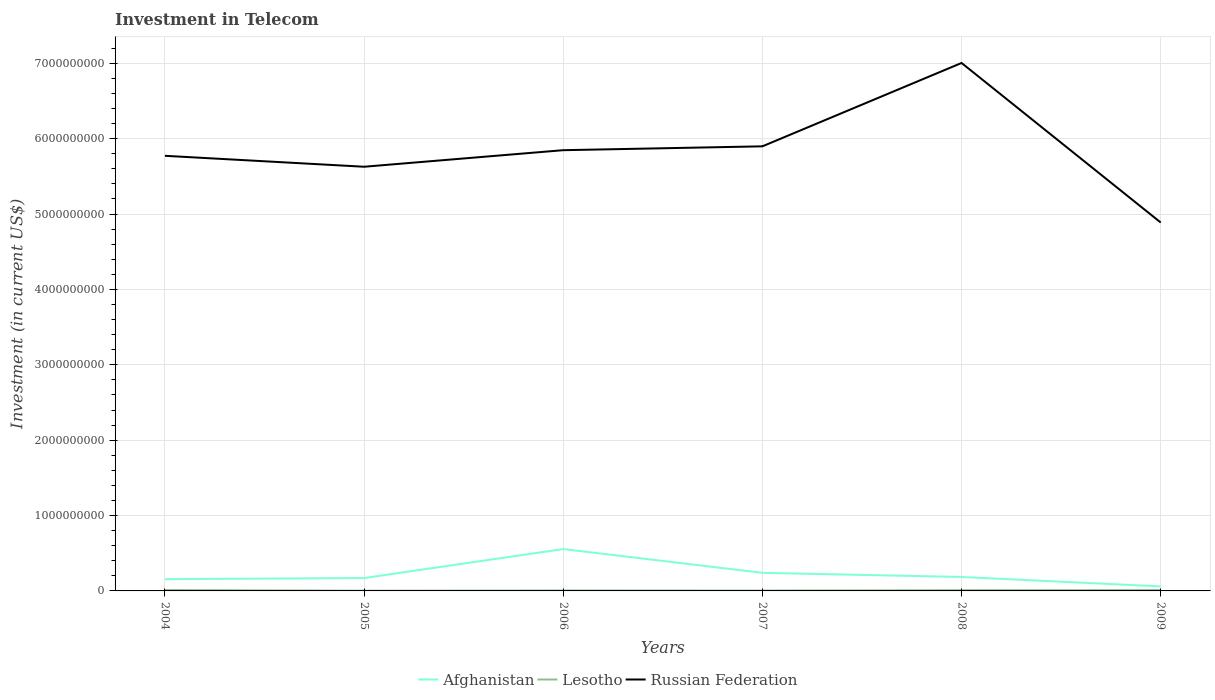How many different coloured lines are there?
Your response must be concise. 3. Is the number of lines equal to the number of legend labels?
Make the answer very short. Yes. Across all years, what is the maximum amount invested in telecom in Russian Federation?
Ensure brevity in your answer.  4.89e+09. In which year was the amount invested in telecom in Russian Federation maximum?
Offer a very short reply. 2009. What is the total amount invested in telecom in Afghanistan in the graph?
Provide a short and direct response. 4.95e+08. What is the difference between the highest and the second highest amount invested in telecom in Afghanistan?
Make the answer very short. 4.95e+08. Is the amount invested in telecom in Lesotho strictly greater than the amount invested in telecom in Russian Federation over the years?
Ensure brevity in your answer.  Yes. How many lines are there?
Provide a succinct answer. 3. How many years are there in the graph?
Offer a terse response. 6. What is the difference between two consecutive major ticks on the Y-axis?
Provide a short and direct response. 1.00e+09. Are the values on the major ticks of Y-axis written in scientific E-notation?
Your answer should be compact. No. Does the graph contain any zero values?
Provide a succinct answer. No. Does the graph contain grids?
Give a very brief answer. Yes. Where does the legend appear in the graph?
Provide a succinct answer. Bottom center. What is the title of the graph?
Your answer should be very brief. Investment in Telecom. What is the label or title of the X-axis?
Give a very brief answer. Years. What is the label or title of the Y-axis?
Give a very brief answer. Investment (in current US$). What is the Investment (in current US$) in Afghanistan in 2004?
Make the answer very short. 1.56e+08. What is the Investment (in current US$) in Lesotho in 2004?
Offer a terse response. 1.15e+07. What is the Investment (in current US$) of Russian Federation in 2004?
Ensure brevity in your answer.  5.77e+09. What is the Investment (in current US$) in Afghanistan in 2005?
Make the answer very short. 1.71e+08. What is the Investment (in current US$) in Lesotho in 2005?
Offer a very short reply. 3.00e+06. What is the Investment (in current US$) in Russian Federation in 2005?
Offer a terse response. 5.63e+09. What is the Investment (in current US$) of Afghanistan in 2006?
Offer a terse response. 5.55e+08. What is the Investment (in current US$) of Lesotho in 2006?
Keep it short and to the point. 5.53e+06. What is the Investment (in current US$) of Russian Federation in 2006?
Offer a very short reply. 5.85e+09. What is the Investment (in current US$) in Afghanistan in 2007?
Your answer should be compact. 2.40e+08. What is the Investment (in current US$) in Lesotho in 2007?
Give a very brief answer. 4.80e+06. What is the Investment (in current US$) in Russian Federation in 2007?
Make the answer very short. 5.90e+09. What is the Investment (in current US$) of Afghanistan in 2008?
Offer a very short reply. 1.85e+08. What is the Investment (in current US$) in Lesotho in 2008?
Offer a very short reply. 9.30e+06. What is the Investment (in current US$) of Russian Federation in 2008?
Provide a short and direct response. 7.00e+09. What is the Investment (in current US$) of Afghanistan in 2009?
Offer a terse response. 6.00e+07. What is the Investment (in current US$) in Lesotho in 2009?
Offer a terse response. 1.10e+07. What is the Investment (in current US$) in Russian Federation in 2009?
Provide a short and direct response. 4.89e+09. Across all years, what is the maximum Investment (in current US$) in Afghanistan?
Provide a succinct answer. 5.55e+08. Across all years, what is the maximum Investment (in current US$) of Lesotho?
Ensure brevity in your answer.  1.15e+07. Across all years, what is the maximum Investment (in current US$) of Russian Federation?
Provide a short and direct response. 7.00e+09. Across all years, what is the minimum Investment (in current US$) in Afghanistan?
Give a very brief answer. 6.00e+07. Across all years, what is the minimum Investment (in current US$) of Lesotho?
Ensure brevity in your answer.  3.00e+06. Across all years, what is the minimum Investment (in current US$) of Russian Federation?
Provide a succinct answer. 4.89e+09. What is the total Investment (in current US$) of Afghanistan in the graph?
Offer a terse response. 1.37e+09. What is the total Investment (in current US$) in Lesotho in the graph?
Offer a terse response. 4.51e+07. What is the total Investment (in current US$) in Russian Federation in the graph?
Provide a succinct answer. 3.50e+1. What is the difference between the Investment (in current US$) in Afghanistan in 2004 and that in 2005?
Ensure brevity in your answer.  -1.51e+07. What is the difference between the Investment (in current US$) in Lesotho in 2004 and that in 2005?
Your response must be concise. 8.50e+06. What is the difference between the Investment (in current US$) in Russian Federation in 2004 and that in 2005?
Provide a short and direct response. 1.45e+08. What is the difference between the Investment (in current US$) in Afghanistan in 2004 and that in 2006?
Give a very brief answer. -3.99e+08. What is the difference between the Investment (in current US$) in Lesotho in 2004 and that in 2006?
Ensure brevity in your answer.  5.97e+06. What is the difference between the Investment (in current US$) of Russian Federation in 2004 and that in 2006?
Your answer should be compact. -7.47e+07. What is the difference between the Investment (in current US$) of Afghanistan in 2004 and that in 2007?
Provide a succinct answer. -8.40e+07. What is the difference between the Investment (in current US$) in Lesotho in 2004 and that in 2007?
Your response must be concise. 6.70e+06. What is the difference between the Investment (in current US$) of Russian Federation in 2004 and that in 2007?
Offer a very short reply. -1.26e+08. What is the difference between the Investment (in current US$) of Afghanistan in 2004 and that in 2008?
Provide a succinct answer. -2.90e+07. What is the difference between the Investment (in current US$) in Lesotho in 2004 and that in 2008?
Your response must be concise. 2.20e+06. What is the difference between the Investment (in current US$) in Russian Federation in 2004 and that in 2008?
Your response must be concise. -1.23e+09. What is the difference between the Investment (in current US$) in Afghanistan in 2004 and that in 2009?
Ensure brevity in your answer.  9.60e+07. What is the difference between the Investment (in current US$) in Lesotho in 2004 and that in 2009?
Keep it short and to the point. 5.00e+05. What is the difference between the Investment (in current US$) in Russian Federation in 2004 and that in 2009?
Your response must be concise. 8.85e+08. What is the difference between the Investment (in current US$) of Afghanistan in 2005 and that in 2006?
Offer a very short reply. -3.84e+08. What is the difference between the Investment (in current US$) of Lesotho in 2005 and that in 2006?
Offer a terse response. -2.53e+06. What is the difference between the Investment (in current US$) of Russian Federation in 2005 and that in 2006?
Offer a very short reply. -2.20e+08. What is the difference between the Investment (in current US$) in Afghanistan in 2005 and that in 2007?
Offer a terse response. -6.89e+07. What is the difference between the Investment (in current US$) in Lesotho in 2005 and that in 2007?
Keep it short and to the point. -1.80e+06. What is the difference between the Investment (in current US$) in Russian Federation in 2005 and that in 2007?
Offer a terse response. -2.71e+08. What is the difference between the Investment (in current US$) in Afghanistan in 2005 and that in 2008?
Ensure brevity in your answer.  -1.39e+07. What is the difference between the Investment (in current US$) in Lesotho in 2005 and that in 2008?
Provide a short and direct response. -6.30e+06. What is the difference between the Investment (in current US$) of Russian Federation in 2005 and that in 2008?
Make the answer very short. -1.38e+09. What is the difference between the Investment (in current US$) of Afghanistan in 2005 and that in 2009?
Provide a succinct answer. 1.11e+08. What is the difference between the Investment (in current US$) in Lesotho in 2005 and that in 2009?
Make the answer very short. -8.00e+06. What is the difference between the Investment (in current US$) in Russian Federation in 2005 and that in 2009?
Offer a terse response. 7.40e+08. What is the difference between the Investment (in current US$) in Afghanistan in 2006 and that in 2007?
Your response must be concise. 3.15e+08. What is the difference between the Investment (in current US$) in Lesotho in 2006 and that in 2007?
Keep it short and to the point. 7.30e+05. What is the difference between the Investment (in current US$) of Russian Federation in 2006 and that in 2007?
Make the answer very short. -5.11e+07. What is the difference between the Investment (in current US$) of Afghanistan in 2006 and that in 2008?
Provide a succinct answer. 3.70e+08. What is the difference between the Investment (in current US$) in Lesotho in 2006 and that in 2008?
Keep it short and to the point. -3.77e+06. What is the difference between the Investment (in current US$) of Russian Federation in 2006 and that in 2008?
Your answer should be very brief. -1.16e+09. What is the difference between the Investment (in current US$) of Afghanistan in 2006 and that in 2009?
Keep it short and to the point. 4.95e+08. What is the difference between the Investment (in current US$) in Lesotho in 2006 and that in 2009?
Ensure brevity in your answer.  -5.47e+06. What is the difference between the Investment (in current US$) of Russian Federation in 2006 and that in 2009?
Offer a very short reply. 9.60e+08. What is the difference between the Investment (in current US$) of Afghanistan in 2007 and that in 2008?
Provide a short and direct response. 5.50e+07. What is the difference between the Investment (in current US$) of Lesotho in 2007 and that in 2008?
Keep it short and to the point. -4.50e+06. What is the difference between the Investment (in current US$) of Russian Federation in 2007 and that in 2008?
Your response must be concise. -1.11e+09. What is the difference between the Investment (in current US$) of Afghanistan in 2007 and that in 2009?
Offer a terse response. 1.80e+08. What is the difference between the Investment (in current US$) in Lesotho in 2007 and that in 2009?
Offer a very short reply. -6.20e+06. What is the difference between the Investment (in current US$) of Russian Federation in 2007 and that in 2009?
Give a very brief answer. 1.01e+09. What is the difference between the Investment (in current US$) of Afghanistan in 2008 and that in 2009?
Make the answer very short. 1.25e+08. What is the difference between the Investment (in current US$) in Lesotho in 2008 and that in 2009?
Give a very brief answer. -1.70e+06. What is the difference between the Investment (in current US$) in Russian Federation in 2008 and that in 2009?
Give a very brief answer. 2.12e+09. What is the difference between the Investment (in current US$) of Afghanistan in 2004 and the Investment (in current US$) of Lesotho in 2005?
Offer a terse response. 1.53e+08. What is the difference between the Investment (in current US$) in Afghanistan in 2004 and the Investment (in current US$) in Russian Federation in 2005?
Give a very brief answer. -5.47e+09. What is the difference between the Investment (in current US$) in Lesotho in 2004 and the Investment (in current US$) in Russian Federation in 2005?
Provide a short and direct response. -5.62e+09. What is the difference between the Investment (in current US$) in Afghanistan in 2004 and the Investment (in current US$) in Lesotho in 2006?
Offer a very short reply. 1.50e+08. What is the difference between the Investment (in current US$) of Afghanistan in 2004 and the Investment (in current US$) of Russian Federation in 2006?
Provide a succinct answer. -5.69e+09. What is the difference between the Investment (in current US$) in Lesotho in 2004 and the Investment (in current US$) in Russian Federation in 2006?
Provide a short and direct response. -5.84e+09. What is the difference between the Investment (in current US$) in Afghanistan in 2004 and the Investment (in current US$) in Lesotho in 2007?
Ensure brevity in your answer.  1.51e+08. What is the difference between the Investment (in current US$) in Afghanistan in 2004 and the Investment (in current US$) in Russian Federation in 2007?
Provide a succinct answer. -5.74e+09. What is the difference between the Investment (in current US$) in Lesotho in 2004 and the Investment (in current US$) in Russian Federation in 2007?
Offer a very short reply. -5.89e+09. What is the difference between the Investment (in current US$) of Afghanistan in 2004 and the Investment (in current US$) of Lesotho in 2008?
Provide a short and direct response. 1.47e+08. What is the difference between the Investment (in current US$) of Afghanistan in 2004 and the Investment (in current US$) of Russian Federation in 2008?
Ensure brevity in your answer.  -6.85e+09. What is the difference between the Investment (in current US$) in Lesotho in 2004 and the Investment (in current US$) in Russian Federation in 2008?
Provide a short and direct response. -6.99e+09. What is the difference between the Investment (in current US$) in Afghanistan in 2004 and the Investment (in current US$) in Lesotho in 2009?
Keep it short and to the point. 1.45e+08. What is the difference between the Investment (in current US$) in Afghanistan in 2004 and the Investment (in current US$) in Russian Federation in 2009?
Keep it short and to the point. -4.73e+09. What is the difference between the Investment (in current US$) in Lesotho in 2004 and the Investment (in current US$) in Russian Federation in 2009?
Keep it short and to the point. -4.88e+09. What is the difference between the Investment (in current US$) of Afghanistan in 2005 and the Investment (in current US$) of Lesotho in 2006?
Make the answer very short. 1.66e+08. What is the difference between the Investment (in current US$) of Afghanistan in 2005 and the Investment (in current US$) of Russian Federation in 2006?
Keep it short and to the point. -5.68e+09. What is the difference between the Investment (in current US$) in Lesotho in 2005 and the Investment (in current US$) in Russian Federation in 2006?
Make the answer very short. -5.84e+09. What is the difference between the Investment (in current US$) of Afghanistan in 2005 and the Investment (in current US$) of Lesotho in 2007?
Ensure brevity in your answer.  1.66e+08. What is the difference between the Investment (in current US$) in Afghanistan in 2005 and the Investment (in current US$) in Russian Federation in 2007?
Ensure brevity in your answer.  -5.73e+09. What is the difference between the Investment (in current US$) of Lesotho in 2005 and the Investment (in current US$) of Russian Federation in 2007?
Provide a short and direct response. -5.90e+09. What is the difference between the Investment (in current US$) in Afghanistan in 2005 and the Investment (in current US$) in Lesotho in 2008?
Your answer should be compact. 1.62e+08. What is the difference between the Investment (in current US$) in Afghanistan in 2005 and the Investment (in current US$) in Russian Federation in 2008?
Your answer should be compact. -6.83e+09. What is the difference between the Investment (in current US$) of Lesotho in 2005 and the Investment (in current US$) of Russian Federation in 2008?
Offer a terse response. -7.00e+09. What is the difference between the Investment (in current US$) of Afghanistan in 2005 and the Investment (in current US$) of Lesotho in 2009?
Your answer should be very brief. 1.60e+08. What is the difference between the Investment (in current US$) of Afghanistan in 2005 and the Investment (in current US$) of Russian Federation in 2009?
Your answer should be compact. -4.72e+09. What is the difference between the Investment (in current US$) of Lesotho in 2005 and the Investment (in current US$) of Russian Federation in 2009?
Ensure brevity in your answer.  -4.88e+09. What is the difference between the Investment (in current US$) of Afghanistan in 2006 and the Investment (in current US$) of Lesotho in 2007?
Your response must be concise. 5.51e+08. What is the difference between the Investment (in current US$) in Afghanistan in 2006 and the Investment (in current US$) in Russian Federation in 2007?
Give a very brief answer. -5.34e+09. What is the difference between the Investment (in current US$) of Lesotho in 2006 and the Investment (in current US$) of Russian Federation in 2007?
Make the answer very short. -5.89e+09. What is the difference between the Investment (in current US$) in Afghanistan in 2006 and the Investment (in current US$) in Lesotho in 2008?
Provide a short and direct response. 5.46e+08. What is the difference between the Investment (in current US$) of Afghanistan in 2006 and the Investment (in current US$) of Russian Federation in 2008?
Ensure brevity in your answer.  -6.45e+09. What is the difference between the Investment (in current US$) in Lesotho in 2006 and the Investment (in current US$) in Russian Federation in 2008?
Your response must be concise. -7.00e+09. What is the difference between the Investment (in current US$) in Afghanistan in 2006 and the Investment (in current US$) in Lesotho in 2009?
Your answer should be very brief. 5.44e+08. What is the difference between the Investment (in current US$) of Afghanistan in 2006 and the Investment (in current US$) of Russian Federation in 2009?
Keep it short and to the point. -4.33e+09. What is the difference between the Investment (in current US$) of Lesotho in 2006 and the Investment (in current US$) of Russian Federation in 2009?
Provide a short and direct response. -4.88e+09. What is the difference between the Investment (in current US$) of Afghanistan in 2007 and the Investment (in current US$) of Lesotho in 2008?
Provide a succinct answer. 2.31e+08. What is the difference between the Investment (in current US$) of Afghanistan in 2007 and the Investment (in current US$) of Russian Federation in 2008?
Your answer should be compact. -6.76e+09. What is the difference between the Investment (in current US$) in Lesotho in 2007 and the Investment (in current US$) in Russian Federation in 2008?
Offer a very short reply. -7.00e+09. What is the difference between the Investment (in current US$) in Afghanistan in 2007 and the Investment (in current US$) in Lesotho in 2009?
Offer a very short reply. 2.29e+08. What is the difference between the Investment (in current US$) in Afghanistan in 2007 and the Investment (in current US$) in Russian Federation in 2009?
Provide a succinct answer. -4.65e+09. What is the difference between the Investment (in current US$) of Lesotho in 2007 and the Investment (in current US$) of Russian Federation in 2009?
Give a very brief answer. -4.88e+09. What is the difference between the Investment (in current US$) in Afghanistan in 2008 and the Investment (in current US$) in Lesotho in 2009?
Give a very brief answer. 1.74e+08. What is the difference between the Investment (in current US$) of Afghanistan in 2008 and the Investment (in current US$) of Russian Federation in 2009?
Ensure brevity in your answer.  -4.70e+09. What is the difference between the Investment (in current US$) in Lesotho in 2008 and the Investment (in current US$) in Russian Federation in 2009?
Your answer should be very brief. -4.88e+09. What is the average Investment (in current US$) in Afghanistan per year?
Provide a short and direct response. 2.28e+08. What is the average Investment (in current US$) of Lesotho per year?
Keep it short and to the point. 7.52e+06. What is the average Investment (in current US$) in Russian Federation per year?
Provide a succinct answer. 5.84e+09. In the year 2004, what is the difference between the Investment (in current US$) of Afghanistan and Investment (in current US$) of Lesotho?
Your answer should be compact. 1.44e+08. In the year 2004, what is the difference between the Investment (in current US$) of Afghanistan and Investment (in current US$) of Russian Federation?
Provide a succinct answer. -5.62e+09. In the year 2004, what is the difference between the Investment (in current US$) in Lesotho and Investment (in current US$) in Russian Federation?
Offer a very short reply. -5.76e+09. In the year 2005, what is the difference between the Investment (in current US$) in Afghanistan and Investment (in current US$) in Lesotho?
Offer a terse response. 1.68e+08. In the year 2005, what is the difference between the Investment (in current US$) of Afghanistan and Investment (in current US$) of Russian Federation?
Provide a short and direct response. -5.46e+09. In the year 2005, what is the difference between the Investment (in current US$) of Lesotho and Investment (in current US$) of Russian Federation?
Offer a very short reply. -5.62e+09. In the year 2006, what is the difference between the Investment (in current US$) of Afghanistan and Investment (in current US$) of Lesotho?
Your answer should be compact. 5.50e+08. In the year 2006, what is the difference between the Investment (in current US$) of Afghanistan and Investment (in current US$) of Russian Federation?
Offer a very short reply. -5.29e+09. In the year 2006, what is the difference between the Investment (in current US$) in Lesotho and Investment (in current US$) in Russian Federation?
Provide a succinct answer. -5.84e+09. In the year 2007, what is the difference between the Investment (in current US$) of Afghanistan and Investment (in current US$) of Lesotho?
Provide a short and direct response. 2.35e+08. In the year 2007, what is the difference between the Investment (in current US$) in Afghanistan and Investment (in current US$) in Russian Federation?
Provide a short and direct response. -5.66e+09. In the year 2007, what is the difference between the Investment (in current US$) in Lesotho and Investment (in current US$) in Russian Federation?
Offer a very short reply. -5.89e+09. In the year 2008, what is the difference between the Investment (in current US$) of Afghanistan and Investment (in current US$) of Lesotho?
Your response must be concise. 1.76e+08. In the year 2008, what is the difference between the Investment (in current US$) in Afghanistan and Investment (in current US$) in Russian Federation?
Give a very brief answer. -6.82e+09. In the year 2008, what is the difference between the Investment (in current US$) in Lesotho and Investment (in current US$) in Russian Federation?
Your response must be concise. -6.99e+09. In the year 2009, what is the difference between the Investment (in current US$) in Afghanistan and Investment (in current US$) in Lesotho?
Ensure brevity in your answer.  4.90e+07. In the year 2009, what is the difference between the Investment (in current US$) of Afghanistan and Investment (in current US$) of Russian Federation?
Your response must be concise. -4.83e+09. In the year 2009, what is the difference between the Investment (in current US$) in Lesotho and Investment (in current US$) in Russian Federation?
Your answer should be very brief. -4.88e+09. What is the ratio of the Investment (in current US$) of Afghanistan in 2004 to that in 2005?
Your answer should be very brief. 0.91. What is the ratio of the Investment (in current US$) in Lesotho in 2004 to that in 2005?
Keep it short and to the point. 3.83. What is the ratio of the Investment (in current US$) in Russian Federation in 2004 to that in 2005?
Your response must be concise. 1.03. What is the ratio of the Investment (in current US$) in Afghanistan in 2004 to that in 2006?
Make the answer very short. 0.28. What is the ratio of the Investment (in current US$) of Lesotho in 2004 to that in 2006?
Offer a very short reply. 2.08. What is the ratio of the Investment (in current US$) in Russian Federation in 2004 to that in 2006?
Provide a short and direct response. 0.99. What is the ratio of the Investment (in current US$) in Afghanistan in 2004 to that in 2007?
Ensure brevity in your answer.  0.65. What is the ratio of the Investment (in current US$) of Lesotho in 2004 to that in 2007?
Make the answer very short. 2.4. What is the ratio of the Investment (in current US$) in Russian Federation in 2004 to that in 2007?
Give a very brief answer. 0.98. What is the ratio of the Investment (in current US$) of Afghanistan in 2004 to that in 2008?
Make the answer very short. 0.84. What is the ratio of the Investment (in current US$) of Lesotho in 2004 to that in 2008?
Make the answer very short. 1.24. What is the ratio of the Investment (in current US$) of Russian Federation in 2004 to that in 2008?
Give a very brief answer. 0.82. What is the ratio of the Investment (in current US$) in Afghanistan in 2004 to that in 2009?
Offer a very short reply. 2.6. What is the ratio of the Investment (in current US$) of Lesotho in 2004 to that in 2009?
Your answer should be very brief. 1.05. What is the ratio of the Investment (in current US$) of Russian Federation in 2004 to that in 2009?
Provide a short and direct response. 1.18. What is the ratio of the Investment (in current US$) of Afghanistan in 2005 to that in 2006?
Provide a succinct answer. 0.31. What is the ratio of the Investment (in current US$) of Lesotho in 2005 to that in 2006?
Provide a succinct answer. 0.54. What is the ratio of the Investment (in current US$) of Russian Federation in 2005 to that in 2006?
Your response must be concise. 0.96. What is the ratio of the Investment (in current US$) of Afghanistan in 2005 to that in 2007?
Offer a terse response. 0.71. What is the ratio of the Investment (in current US$) in Lesotho in 2005 to that in 2007?
Give a very brief answer. 0.62. What is the ratio of the Investment (in current US$) of Russian Federation in 2005 to that in 2007?
Your answer should be very brief. 0.95. What is the ratio of the Investment (in current US$) in Afghanistan in 2005 to that in 2008?
Ensure brevity in your answer.  0.92. What is the ratio of the Investment (in current US$) in Lesotho in 2005 to that in 2008?
Offer a terse response. 0.32. What is the ratio of the Investment (in current US$) in Russian Federation in 2005 to that in 2008?
Your answer should be compact. 0.8. What is the ratio of the Investment (in current US$) of Afghanistan in 2005 to that in 2009?
Your answer should be very brief. 2.85. What is the ratio of the Investment (in current US$) of Lesotho in 2005 to that in 2009?
Give a very brief answer. 0.27. What is the ratio of the Investment (in current US$) in Russian Federation in 2005 to that in 2009?
Your answer should be very brief. 1.15. What is the ratio of the Investment (in current US$) in Afghanistan in 2006 to that in 2007?
Give a very brief answer. 2.31. What is the ratio of the Investment (in current US$) in Lesotho in 2006 to that in 2007?
Your response must be concise. 1.15. What is the ratio of the Investment (in current US$) in Russian Federation in 2006 to that in 2007?
Offer a very short reply. 0.99. What is the ratio of the Investment (in current US$) in Afghanistan in 2006 to that in 2008?
Provide a short and direct response. 3. What is the ratio of the Investment (in current US$) in Lesotho in 2006 to that in 2008?
Offer a terse response. 0.59. What is the ratio of the Investment (in current US$) of Russian Federation in 2006 to that in 2008?
Provide a succinct answer. 0.83. What is the ratio of the Investment (in current US$) in Afghanistan in 2006 to that in 2009?
Your answer should be very brief. 9.26. What is the ratio of the Investment (in current US$) of Lesotho in 2006 to that in 2009?
Keep it short and to the point. 0.5. What is the ratio of the Investment (in current US$) in Russian Federation in 2006 to that in 2009?
Give a very brief answer. 1.2. What is the ratio of the Investment (in current US$) in Afghanistan in 2007 to that in 2008?
Give a very brief answer. 1.3. What is the ratio of the Investment (in current US$) of Lesotho in 2007 to that in 2008?
Keep it short and to the point. 0.52. What is the ratio of the Investment (in current US$) in Russian Federation in 2007 to that in 2008?
Your answer should be very brief. 0.84. What is the ratio of the Investment (in current US$) in Lesotho in 2007 to that in 2009?
Your answer should be very brief. 0.44. What is the ratio of the Investment (in current US$) of Russian Federation in 2007 to that in 2009?
Keep it short and to the point. 1.21. What is the ratio of the Investment (in current US$) of Afghanistan in 2008 to that in 2009?
Offer a terse response. 3.08. What is the ratio of the Investment (in current US$) in Lesotho in 2008 to that in 2009?
Provide a short and direct response. 0.85. What is the ratio of the Investment (in current US$) in Russian Federation in 2008 to that in 2009?
Your answer should be compact. 1.43. What is the difference between the highest and the second highest Investment (in current US$) of Afghanistan?
Give a very brief answer. 3.15e+08. What is the difference between the highest and the second highest Investment (in current US$) of Russian Federation?
Ensure brevity in your answer.  1.11e+09. What is the difference between the highest and the lowest Investment (in current US$) of Afghanistan?
Make the answer very short. 4.95e+08. What is the difference between the highest and the lowest Investment (in current US$) of Lesotho?
Make the answer very short. 8.50e+06. What is the difference between the highest and the lowest Investment (in current US$) in Russian Federation?
Offer a terse response. 2.12e+09. 